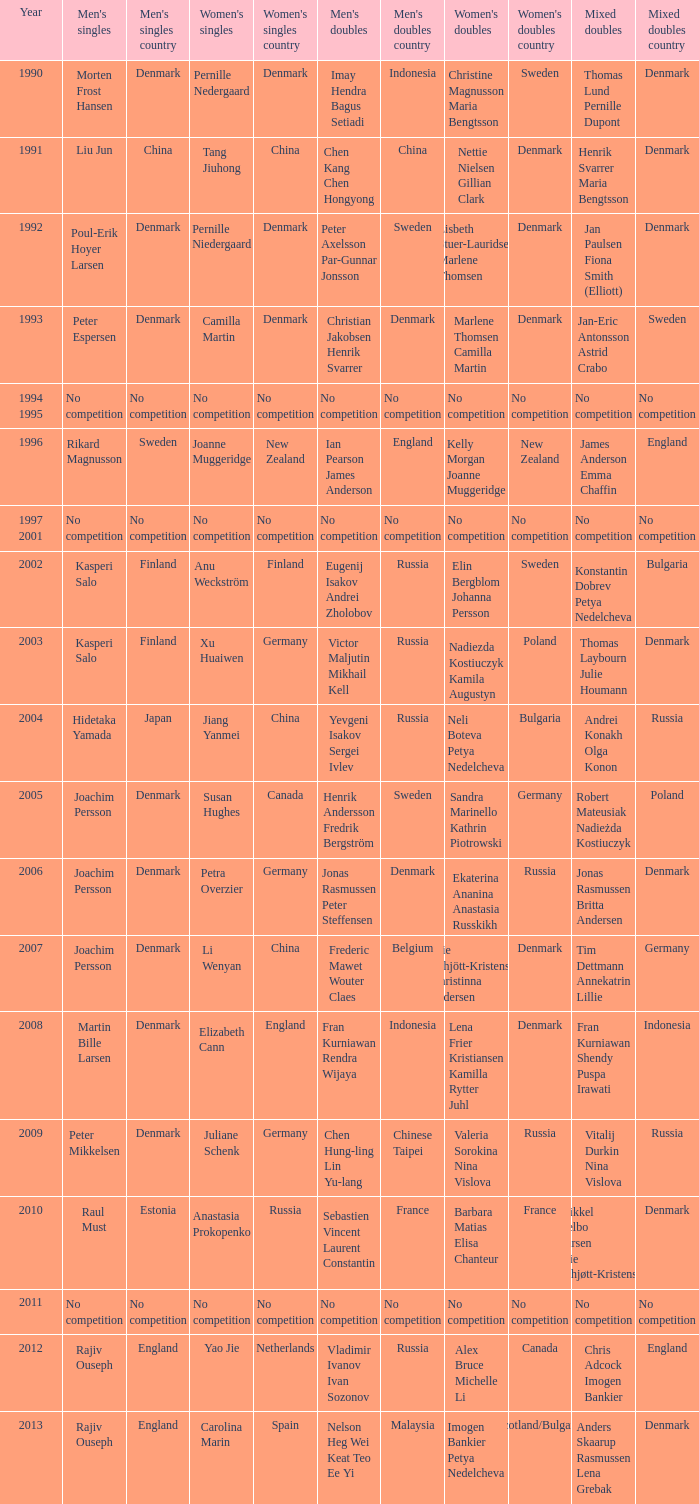In which year did carolina marin secure the women's singles title? 2013.0. 